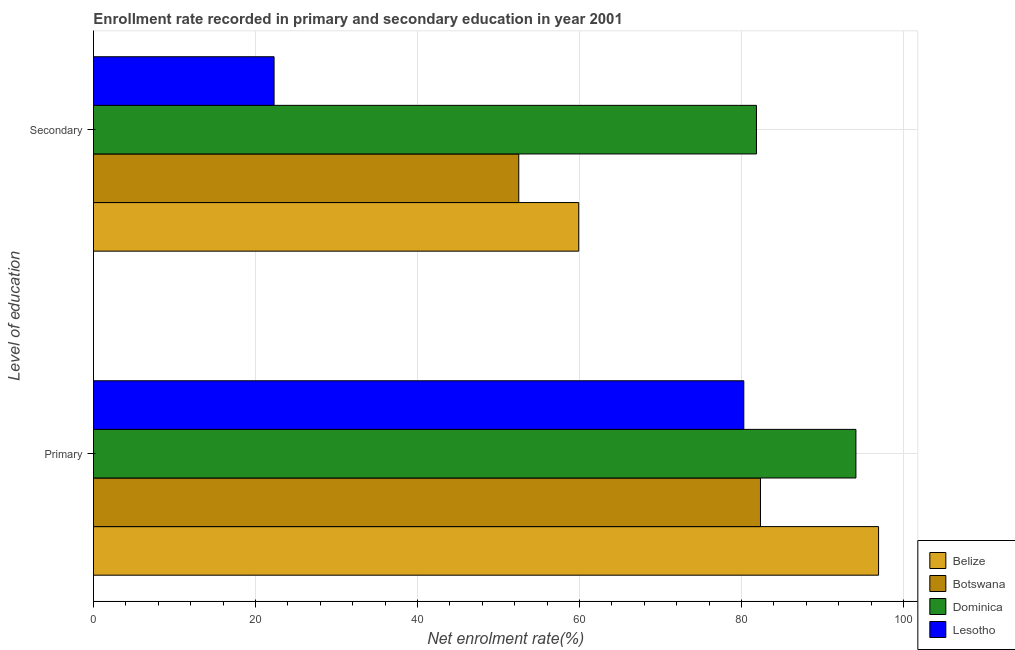How many groups of bars are there?
Offer a terse response. 2. What is the label of the 2nd group of bars from the top?
Give a very brief answer. Primary. What is the enrollment rate in primary education in Dominica?
Your answer should be compact. 94.13. Across all countries, what is the maximum enrollment rate in primary education?
Provide a short and direct response. 96.92. Across all countries, what is the minimum enrollment rate in secondary education?
Your answer should be very brief. 22.3. In which country was the enrollment rate in primary education maximum?
Give a very brief answer. Belize. In which country was the enrollment rate in secondary education minimum?
Provide a succinct answer. Lesotho. What is the total enrollment rate in secondary education in the graph?
Your answer should be very brief. 216.55. What is the difference between the enrollment rate in primary education in Dominica and that in Belize?
Give a very brief answer. -2.79. What is the difference between the enrollment rate in primary education in Dominica and the enrollment rate in secondary education in Belize?
Offer a terse response. 34.22. What is the average enrollment rate in primary education per country?
Provide a succinct answer. 88.42. What is the difference between the enrollment rate in secondary education and enrollment rate in primary education in Botswana?
Your answer should be compact. -29.84. What is the ratio of the enrollment rate in primary education in Belize to that in Botswana?
Provide a short and direct response. 1.18. Is the enrollment rate in secondary education in Botswana less than that in Belize?
Give a very brief answer. Yes. In how many countries, is the enrollment rate in primary education greater than the average enrollment rate in primary education taken over all countries?
Your answer should be very brief. 2. What does the 1st bar from the top in Secondary represents?
Offer a terse response. Lesotho. What does the 3rd bar from the bottom in Secondary represents?
Your answer should be very brief. Dominica. How many bars are there?
Ensure brevity in your answer.  8. How many countries are there in the graph?
Your response must be concise. 4. What is the difference between two consecutive major ticks on the X-axis?
Provide a succinct answer. 20. Are the values on the major ticks of X-axis written in scientific E-notation?
Offer a terse response. No. How are the legend labels stacked?
Offer a very short reply. Vertical. What is the title of the graph?
Your answer should be compact. Enrollment rate recorded in primary and secondary education in year 2001. What is the label or title of the X-axis?
Your answer should be very brief. Net enrolment rate(%). What is the label or title of the Y-axis?
Offer a terse response. Level of education. What is the Net enrolment rate(%) in Belize in Primary?
Keep it short and to the point. 96.92. What is the Net enrolment rate(%) of Botswana in Primary?
Provide a short and direct response. 82.34. What is the Net enrolment rate(%) of Dominica in Primary?
Keep it short and to the point. 94.13. What is the Net enrolment rate(%) of Lesotho in Primary?
Offer a very short reply. 80.29. What is the Net enrolment rate(%) of Belize in Secondary?
Your answer should be very brief. 59.9. What is the Net enrolment rate(%) in Botswana in Secondary?
Your answer should be compact. 52.5. What is the Net enrolment rate(%) in Dominica in Secondary?
Ensure brevity in your answer.  81.85. What is the Net enrolment rate(%) of Lesotho in Secondary?
Give a very brief answer. 22.3. Across all Level of education, what is the maximum Net enrolment rate(%) of Belize?
Your answer should be very brief. 96.92. Across all Level of education, what is the maximum Net enrolment rate(%) in Botswana?
Keep it short and to the point. 82.34. Across all Level of education, what is the maximum Net enrolment rate(%) of Dominica?
Your response must be concise. 94.13. Across all Level of education, what is the maximum Net enrolment rate(%) in Lesotho?
Give a very brief answer. 80.29. Across all Level of education, what is the minimum Net enrolment rate(%) in Belize?
Your response must be concise. 59.9. Across all Level of education, what is the minimum Net enrolment rate(%) in Botswana?
Your answer should be compact. 52.5. Across all Level of education, what is the minimum Net enrolment rate(%) of Dominica?
Your answer should be very brief. 81.85. Across all Level of education, what is the minimum Net enrolment rate(%) of Lesotho?
Offer a terse response. 22.3. What is the total Net enrolment rate(%) of Belize in the graph?
Make the answer very short. 156.83. What is the total Net enrolment rate(%) in Botswana in the graph?
Give a very brief answer. 134.85. What is the total Net enrolment rate(%) in Dominica in the graph?
Your answer should be compact. 175.97. What is the total Net enrolment rate(%) of Lesotho in the graph?
Make the answer very short. 102.58. What is the difference between the Net enrolment rate(%) of Belize in Primary and that in Secondary?
Offer a terse response. 37.02. What is the difference between the Net enrolment rate(%) of Botswana in Primary and that in Secondary?
Offer a very short reply. 29.84. What is the difference between the Net enrolment rate(%) in Dominica in Primary and that in Secondary?
Your answer should be compact. 12.28. What is the difference between the Net enrolment rate(%) of Lesotho in Primary and that in Secondary?
Provide a short and direct response. 57.99. What is the difference between the Net enrolment rate(%) in Belize in Primary and the Net enrolment rate(%) in Botswana in Secondary?
Your answer should be very brief. 44.42. What is the difference between the Net enrolment rate(%) in Belize in Primary and the Net enrolment rate(%) in Dominica in Secondary?
Give a very brief answer. 15.07. What is the difference between the Net enrolment rate(%) of Belize in Primary and the Net enrolment rate(%) of Lesotho in Secondary?
Your answer should be very brief. 74.63. What is the difference between the Net enrolment rate(%) in Botswana in Primary and the Net enrolment rate(%) in Dominica in Secondary?
Your answer should be very brief. 0.49. What is the difference between the Net enrolment rate(%) of Botswana in Primary and the Net enrolment rate(%) of Lesotho in Secondary?
Your answer should be compact. 60.05. What is the difference between the Net enrolment rate(%) of Dominica in Primary and the Net enrolment rate(%) of Lesotho in Secondary?
Provide a short and direct response. 71.83. What is the average Net enrolment rate(%) of Belize per Level of education?
Make the answer very short. 78.41. What is the average Net enrolment rate(%) of Botswana per Level of education?
Provide a short and direct response. 67.42. What is the average Net enrolment rate(%) in Dominica per Level of education?
Make the answer very short. 87.99. What is the average Net enrolment rate(%) in Lesotho per Level of education?
Keep it short and to the point. 51.29. What is the difference between the Net enrolment rate(%) of Belize and Net enrolment rate(%) of Botswana in Primary?
Your answer should be compact. 14.58. What is the difference between the Net enrolment rate(%) of Belize and Net enrolment rate(%) of Dominica in Primary?
Provide a short and direct response. 2.79. What is the difference between the Net enrolment rate(%) of Belize and Net enrolment rate(%) of Lesotho in Primary?
Provide a short and direct response. 16.63. What is the difference between the Net enrolment rate(%) of Botswana and Net enrolment rate(%) of Dominica in Primary?
Your answer should be very brief. -11.78. What is the difference between the Net enrolment rate(%) in Botswana and Net enrolment rate(%) in Lesotho in Primary?
Your response must be concise. 2.06. What is the difference between the Net enrolment rate(%) in Dominica and Net enrolment rate(%) in Lesotho in Primary?
Provide a short and direct response. 13.84. What is the difference between the Net enrolment rate(%) in Belize and Net enrolment rate(%) in Botswana in Secondary?
Make the answer very short. 7.4. What is the difference between the Net enrolment rate(%) of Belize and Net enrolment rate(%) of Dominica in Secondary?
Your response must be concise. -21.94. What is the difference between the Net enrolment rate(%) of Belize and Net enrolment rate(%) of Lesotho in Secondary?
Provide a succinct answer. 37.61. What is the difference between the Net enrolment rate(%) of Botswana and Net enrolment rate(%) of Dominica in Secondary?
Your answer should be very brief. -29.34. What is the difference between the Net enrolment rate(%) in Botswana and Net enrolment rate(%) in Lesotho in Secondary?
Make the answer very short. 30.21. What is the difference between the Net enrolment rate(%) in Dominica and Net enrolment rate(%) in Lesotho in Secondary?
Your response must be concise. 59.55. What is the ratio of the Net enrolment rate(%) of Belize in Primary to that in Secondary?
Offer a terse response. 1.62. What is the ratio of the Net enrolment rate(%) of Botswana in Primary to that in Secondary?
Your answer should be compact. 1.57. What is the ratio of the Net enrolment rate(%) in Dominica in Primary to that in Secondary?
Offer a very short reply. 1.15. What is the ratio of the Net enrolment rate(%) in Lesotho in Primary to that in Secondary?
Provide a short and direct response. 3.6. What is the difference between the highest and the second highest Net enrolment rate(%) of Belize?
Your answer should be compact. 37.02. What is the difference between the highest and the second highest Net enrolment rate(%) of Botswana?
Ensure brevity in your answer.  29.84. What is the difference between the highest and the second highest Net enrolment rate(%) of Dominica?
Your answer should be very brief. 12.28. What is the difference between the highest and the second highest Net enrolment rate(%) of Lesotho?
Offer a very short reply. 57.99. What is the difference between the highest and the lowest Net enrolment rate(%) of Belize?
Make the answer very short. 37.02. What is the difference between the highest and the lowest Net enrolment rate(%) in Botswana?
Your answer should be very brief. 29.84. What is the difference between the highest and the lowest Net enrolment rate(%) of Dominica?
Your response must be concise. 12.28. What is the difference between the highest and the lowest Net enrolment rate(%) of Lesotho?
Your response must be concise. 57.99. 